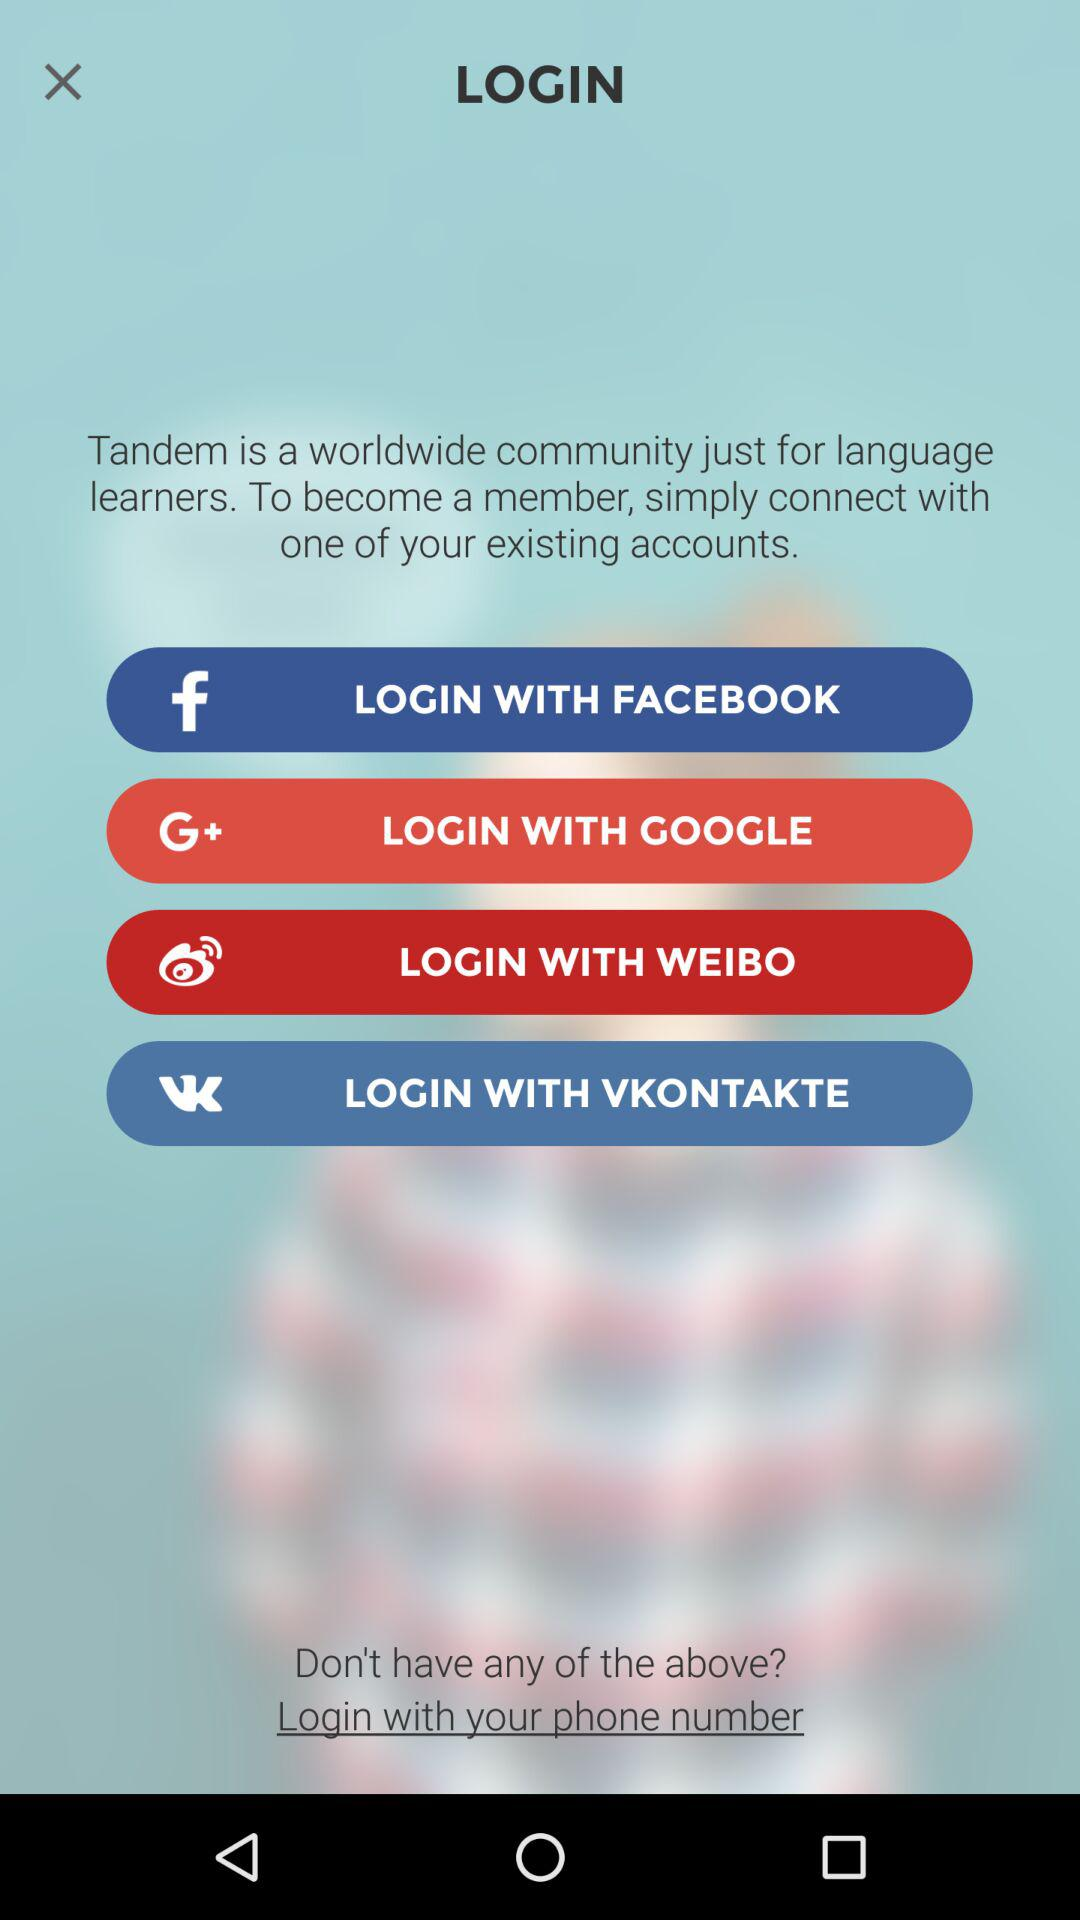How many social media platforms can I log in with?
Answer the question using a single word or phrase. 4 